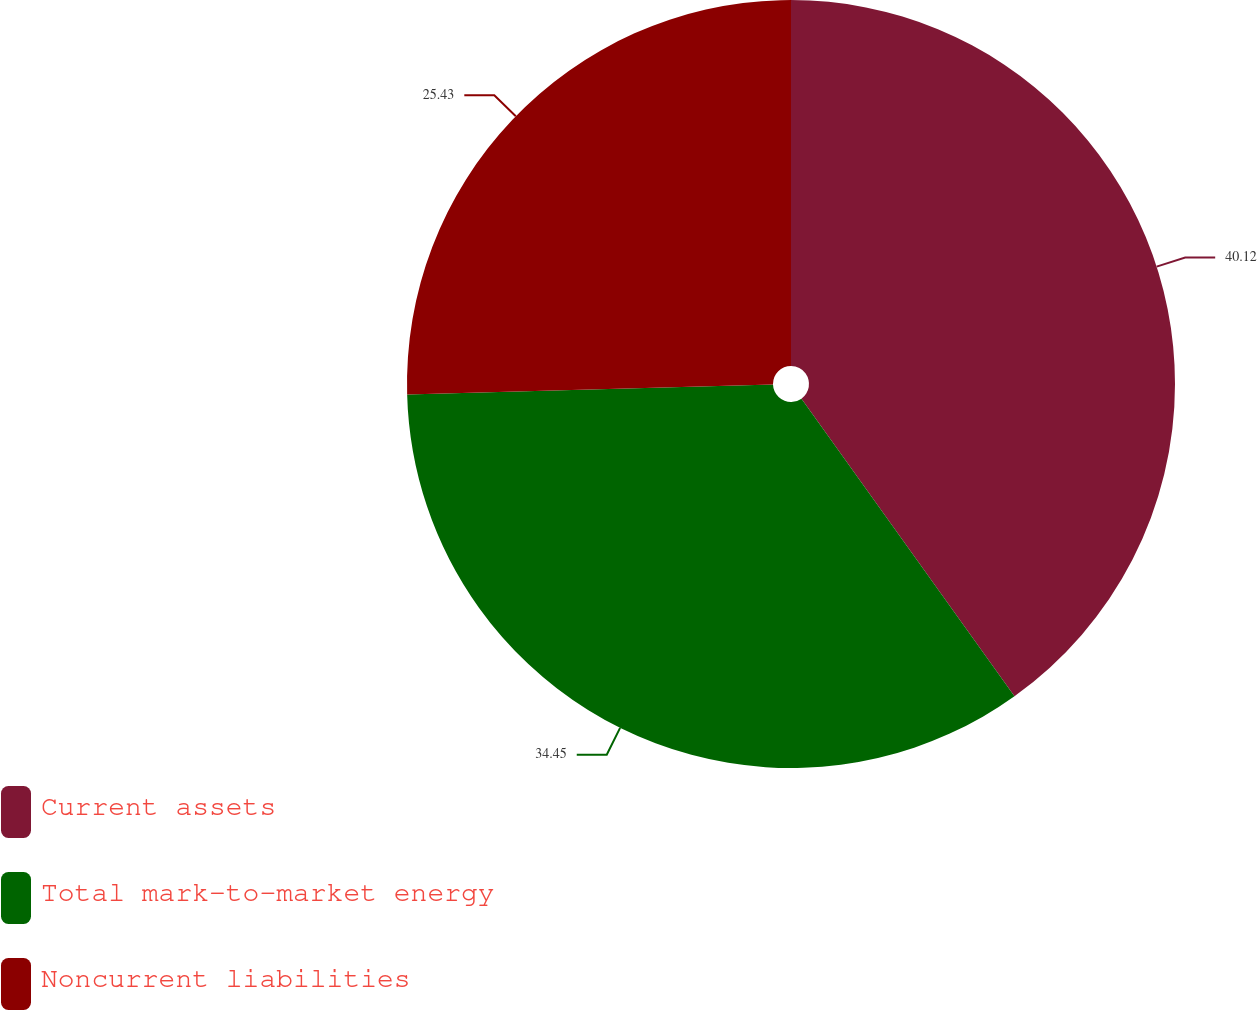Convert chart. <chart><loc_0><loc_0><loc_500><loc_500><pie_chart><fcel>Current assets<fcel>Total mark-to-market energy<fcel>Noncurrent liabilities<nl><fcel>40.11%<fcel>34.45%<fcel>25.43%<nl></chart> 